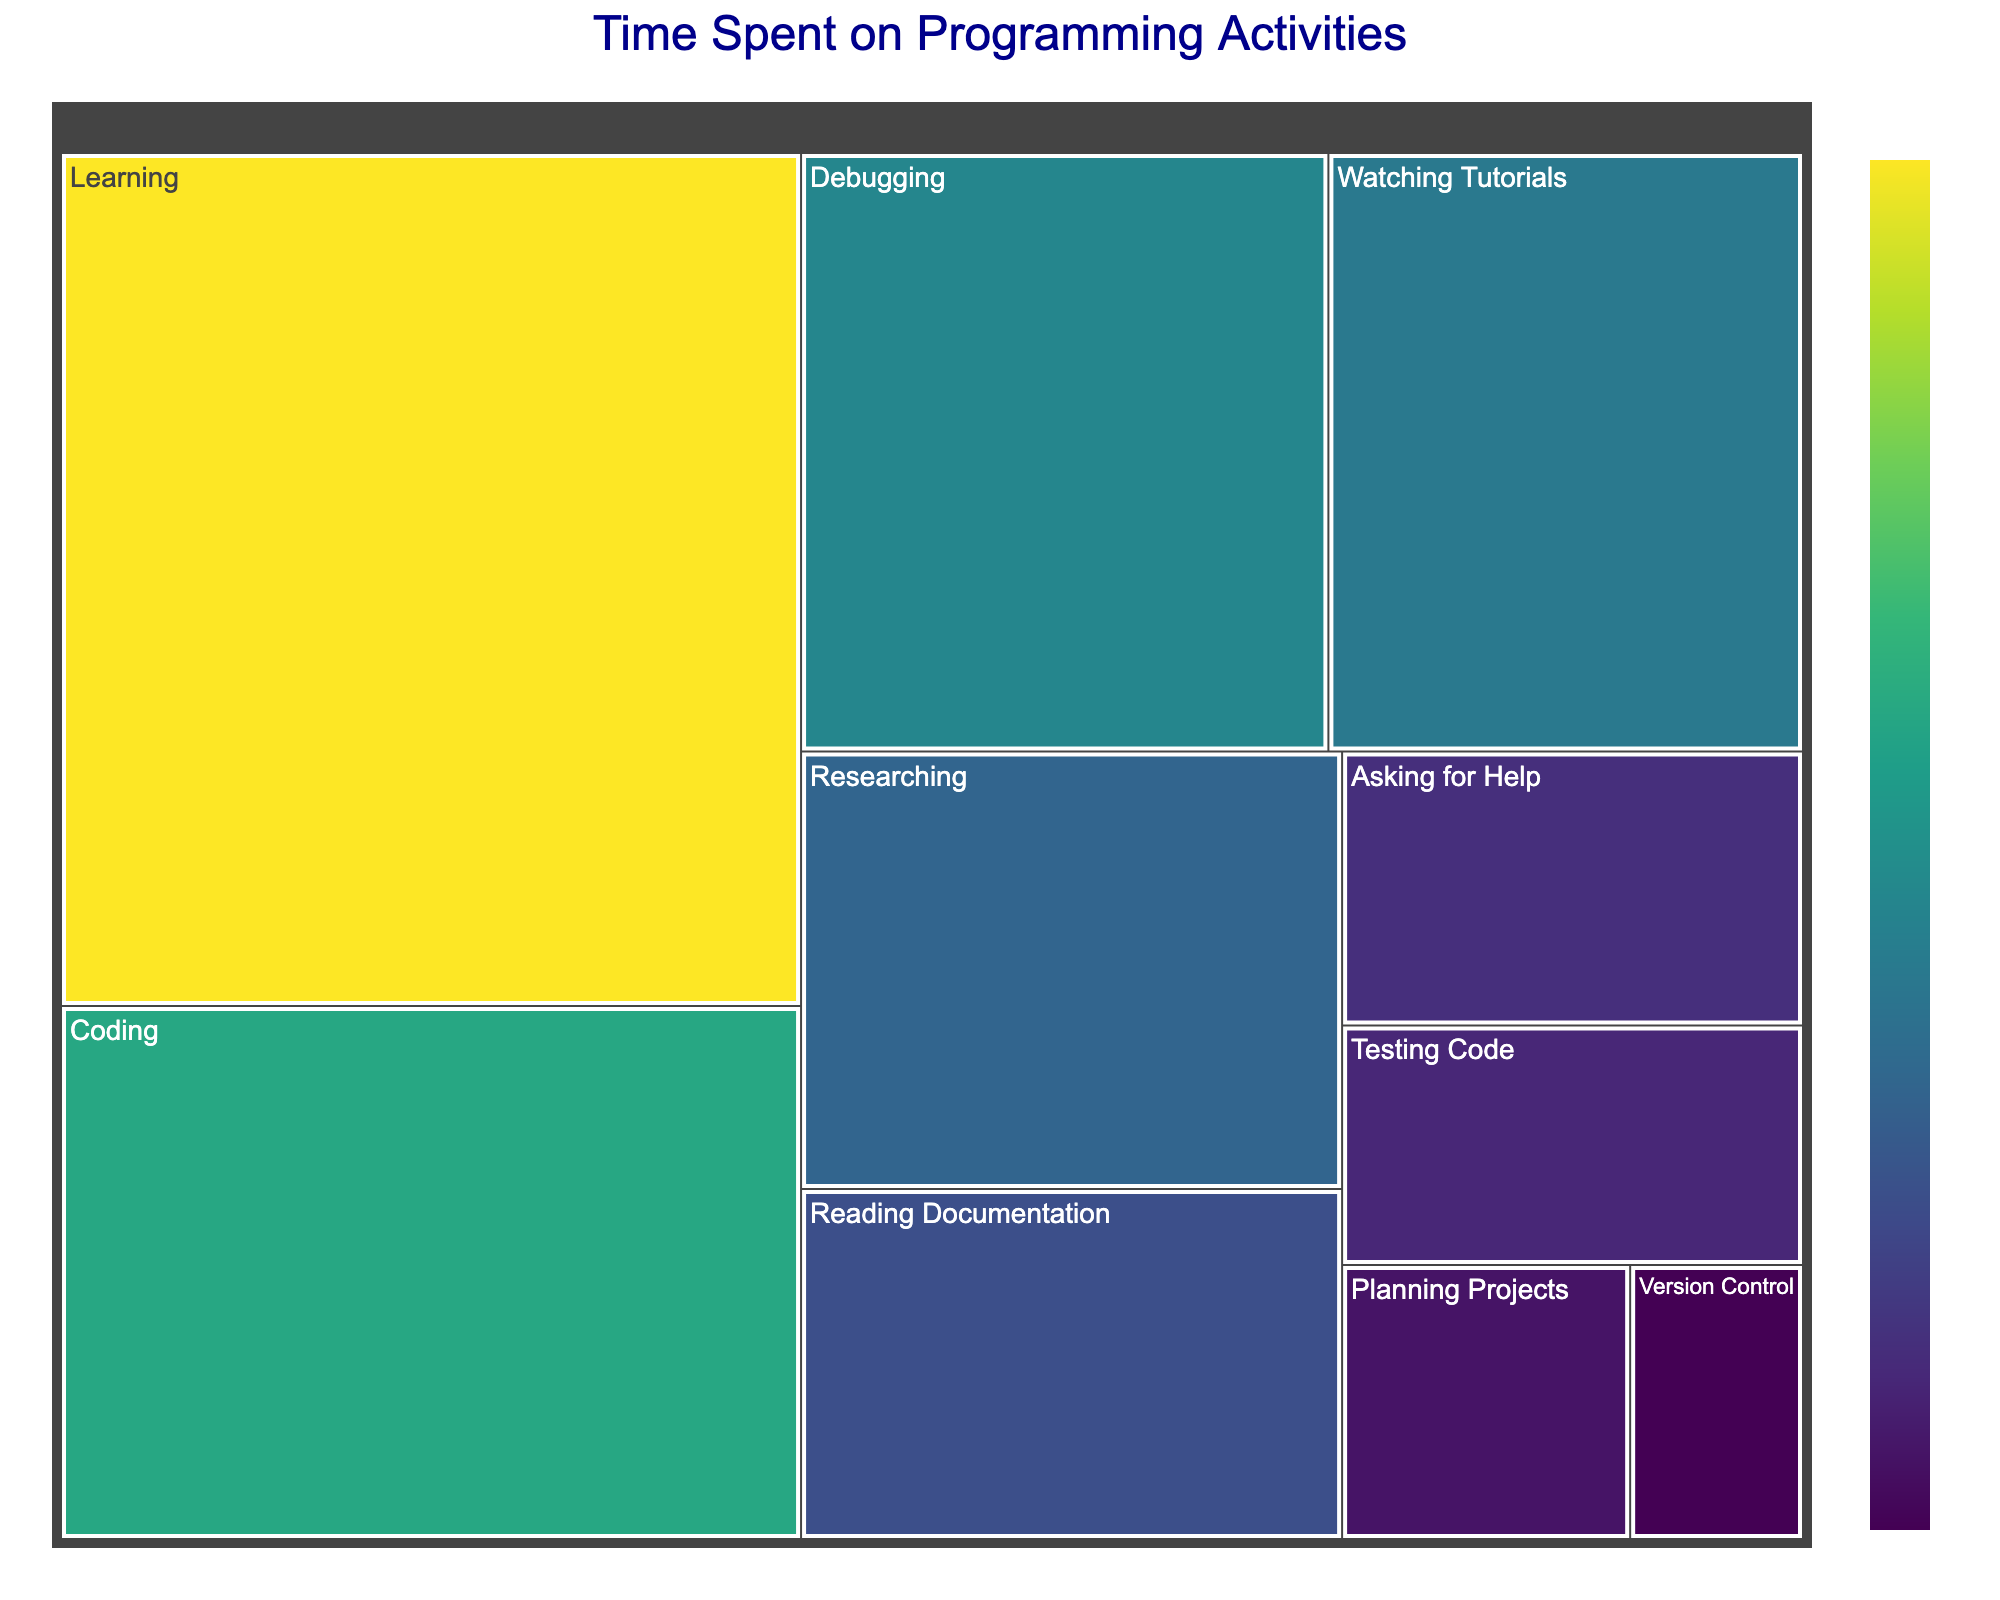What is the title of the figure? The title of the figure is found at the top and provides a summary of what the figure represents. In this case, it's displayed prominently in dark blue text above the treemap.
Answer: Time Spent on Programming Activities Which activity has the highest time spent according to the treemap? Each rectangle in the treemap represents a programming activity, and the size correlates with the time spent. The largest rectangle represents the activity with the most time spent.
Answer: Learning What is the smallest rectangle in the treemap and its value? By examining the smallest rectangle in the treemap, we can identify it and check the hover information or the size to know its value.
Answer: Version Control, 3 hours What is the color scheme used in the treemap to represent different activities? The color scheme is a visual representation. By looking at the treemap, one can determine the color palette used to differentiate the activities.
Answer: Viridis scale (ranging from light to dark hues of green to purple) 